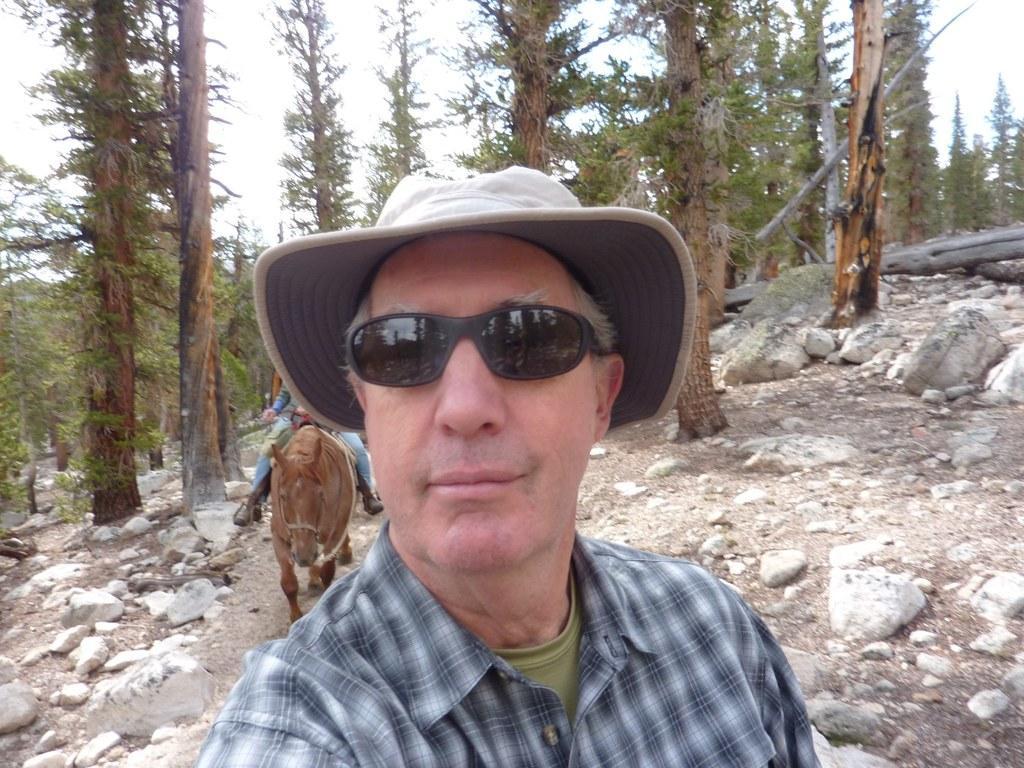Could you give a brief overview of what you see in this image? In this picture this person wore glasses and cap. There is a person sitting on the donkey. In this background we can see some trees and sky. There are few stones. 